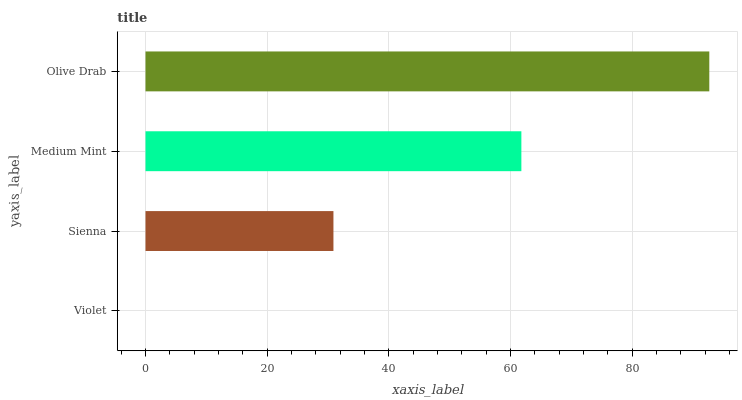Is Violet the minimum?
Answer yes or no. Yes. Is Olive Drab the maximum?
Answer yes or no. Yes. Is Sienna the minimum?
Answer yes or no. No. Is Sienna the maximum?
Answer yes or no. No. Is Sienna greater than Violet?
Answer yes or no. Yes. Is Violet less than Sienna?
Answer yes or no. Yes. Is Violet greater than Sienna?
Answer yes or no. No. Is Sienna less than Violet?
Answer yes or no. No. Is Medium Mint the high median?
Answer yes or no. Yes. Is Sienna the low median?
Answer yes or no. Yes. Is Violet the high median?
Answer yes or no. No. Is Olive Drab the low median?
Answer yes or no. No. 